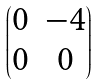<formula> <loc_0><loc_0><loc_500><loc_500>\begin{pmatrix} 0 & - 4 \\ 0 & 0 \end{pmatrix}</formula> 